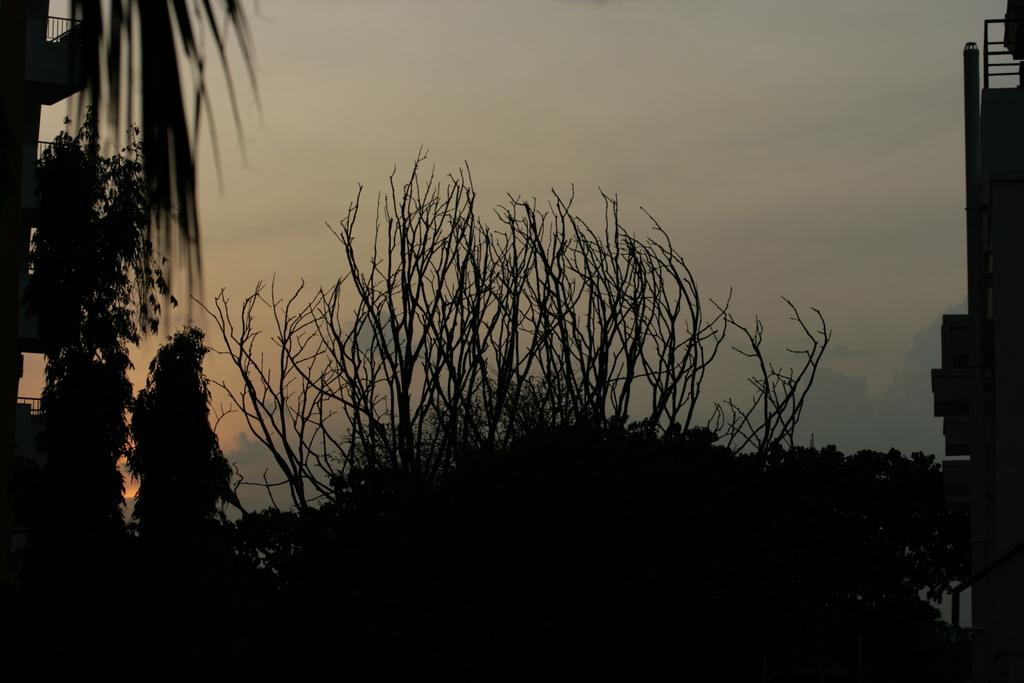What type of natural elements can be seen in the image? There are trees in the image. What type of man-made structures are present in the image? There are buildings in the image. What type of infrastructure can be seen in the image? There are pipes in the image. What is visible at the top of the image? The sky is visible at the top of the image. What type of rice is being served in the image? There is no rice present in the image; it features trees, buildings, pipes, and the sky. How many zippers can be seen on the trees in the image? There are no zippers present on the trees in the image; it features trees, buildings, pipes, and the sky. 